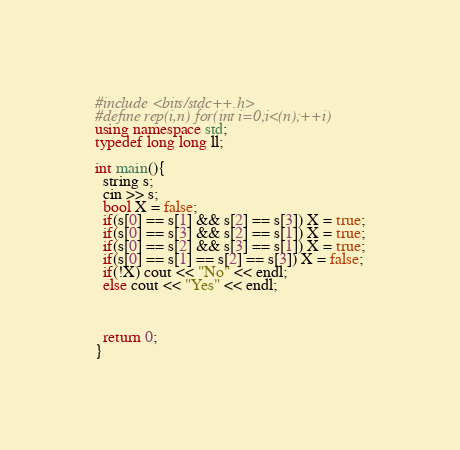Convert code to text. <code><loc_0><loc_0><loc_500><loc_500><_C++_>#include <bits/stdc++.h>
#define rep(i,n) for(int i=0;i<(n);++i)
using namespace std;
typedef long long ll;

int main(){
  string s;
  cin >> s;
  bool X = false;
  if(s[0] == s[1] && s[2] == s[3]) X = true;
  if(s[0] == s[3] && s[2] == s[1]) X = true;
  if(s[0] == s[2] && s[3] == s[1]) X = true;
  if(s[0] == s[1] == s[2] == s[3]) X = false;
  if(!X) cout << "No" << endl;
  else cout << "Yes" << endl;
  


  return 0;
}</code> 